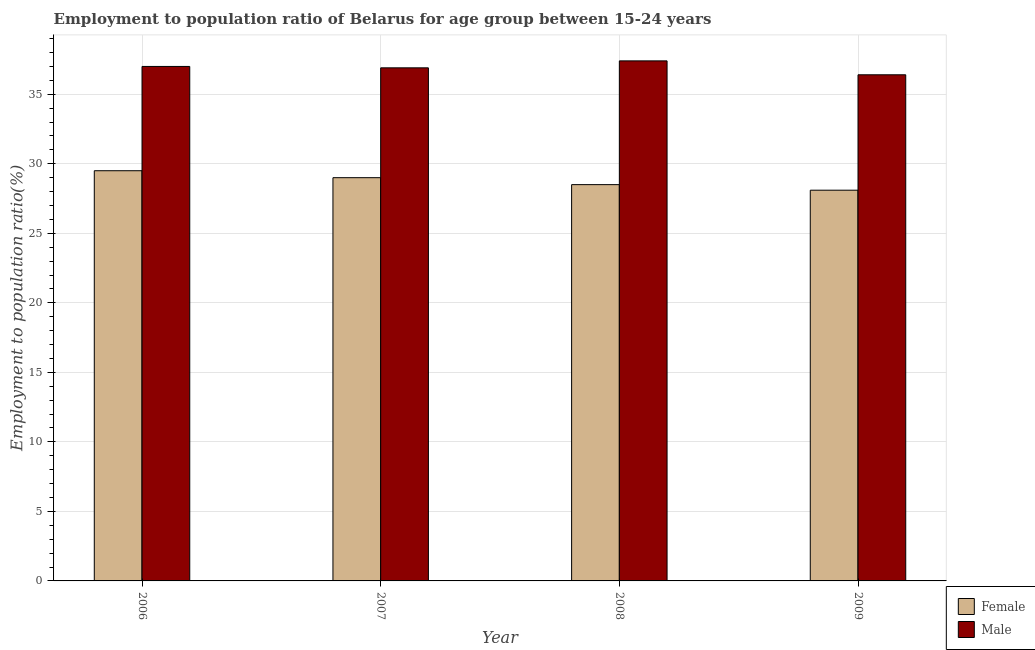Are the number of bars per tick equal to the number of legend labels?
Your answer should be very brief. Yes. What is the label of the 4th group of bars from the left?
Your answer should be very brief. 2009. What is the employment to population ratio(male) in 2009?
Your answer should be very brief. 36.4. Across all years, what is the maximum employment to population ratio(male)?
Offer a terse response. 37.4. Across all years, what is the minimum employment to population ratio(male)?
Make the answer very short. 36.4. In which year was the employment to population ratio(male) minimum?
Give a very brief answer. 2009. What is the total employment to population ratio(male) in the graph?
Make the answer very short. 147.7. What is the difference between the employment to population ratio(female) in 2009 and the employment to population ratio(male) in 2006?
Your answer should be compact. -1.4. What is the average employment to population ratio(male) per year?
Give a very brief answer. 36.93. What is the ratio of the employment to population ratio(female) in 2006 to that in 2007?
Make the answer very short. 1.02. Is the difference between the employment to population ratio(male) in 2006 and 2009 greater than the difference between the employment to population ratio(female) in 2006 and 2009?
Keep it short and to the point. No. What is the difference between the highest and the lowest employment to population ratio(female)?
Provide a short and direct response. 1.4. Is the sum of the employment to population ratio(female) in 2006 and 2008 greater than the maximum employment to population ratio(male) across all years?
Your response must be concise. Yes. What does the 2nd bar from the left in 2007 represents?
Your response must be concise. Male. Are all the bars in the graph horizontal?
Offer a very short reply. No. How many years are there in the graph?
Ensure brevity in your answer.  4. Are the values on the major ticks of Y-axis written in scientific E-notation?
Give a very brief answer. No. Where does the legend appear in the graph?
Make the answer very short. Bottom right. How many legend labels are there?
Ensure brevity in your answer.  2. What is the title of the graph?
Your answer should be compact. Employment to population ratio of Belarus for age group between 15-24 years. Does "Primary" appear as one of the legend labels in the graph?
Keep it short and to the point. No. What is the label or title of the X-axis?
Make the answer very short. Year. What is the label or title of the Y-axis?
Your answer should be very brief. Employment to population ratio(%). What is the Employment to population ratio(%) in Female in 2006?
Your answer should be very brief. 29.5. What is the Employment to population ratio(%) in Male in 2006?
Provide a short and direct response. 37. What is the Employment to population ratio(%) of Male in 2007?
Your answer should be very brief. 36.9. What is the Employment to population ratio(%) in Female in 2008?
Offer a terse response. 28.5. What is the Employment to population ratio(%) in Male in 2008?
Your response must be concise. 37.4. What is the Employment to population ratio(%) of Female in 2009?
Offer a terse response. 28.1. What is the Employment to population ratio(%) in Male in 2009?
Provide a short and direct response. 36.4. Across all years, what is the maximum Employment to population ratio(%) in Female?
Offer a terse response. 29.5. Across all years, what is the maximum Employment to population ratio(%) of Male?
Offer a very short reply. 37.4. Across all years, what is the minimum Employment to population ratio(%) of Female?
Offer a terse response. 28.1. Across all years, what is the minimum Employment to population ratio(%) in Male?
Your answer should be compact. 36.4. What is the total Employment to population ratio(%) of Female in the graph?
Your answer should be very brief. 115.1. What is the total Employment to population ratio(%) in Male in the graph?
Keep it short and to the point. 147.7. What is the difference between the Employment to population ratio(%) in Female in 2006 and that in 2007?
Ensure brevity in your answer.  0.5. What is the difference between the Employment to population ratio(%) of Male in 2006 and that in 2008?
Your answer should be very brief. -0.4. What is the difference between the Employment to population ratio(%) in Female in 2006 and that in 2009?
Ensure brevity in your answer.  1.4. What is the difference between the Employment to population ratio(%) of Male in 2006 and that in 2009?
Your answer should be very brief. 0.6. What is the difference between the Employment to population ratio(%) in Male in 2007 and that in 2008?
Your response must be concise. -0.5. What is the difference between the Employment to population ratio(%) in Male in 2008 and that in 2009?
Your answer should be compact. 1. What is the difference between the Employment to population ratio(%) of Female in 2007 and the Employment to population ratio(%) of Male in 2008?
Ensure brevity in your answer.  -8.4. What is the difference between the Employment to population ratio(%) of Female in 2008 and the Employment to population ratio(%) of Male in 2009?
Your response must be concise. -7.9. What is the average Employment to population ratio(%) of Female per year?
Make the answer very short. 28.77. What is the average Employment to population ratio(%) in Male per year?
Give a very brief answer. 36.92. In the year 2006, what is the difference between the Employment to population ratio(%) in Female and Employment to population ratio(%) in Male?
Your answer should be very brief. -7.5. In the year 2007, what is the difference between the Employment to population ratio(%) in Female and Employment to population ratio(%) in Male?
Make the answer very short. -7.9. In the year 2008, what is the difference between the Employment to population ratio(%) of Female and Employment to population ratio(%) of Male?
Give a very brief answer. -8.9. What is the ratio of the Employment to population ratio(%) in Female in 2006 to that in 2007?
Your answer should be very brief. 1.02. What is the ratio of the Employment to population ratio(%) in Male in 2006 to that in 2007?
Offer a terse response. 1. What is the ratio of the Employment to population ratio(%) of Female in 2006 to that in 2008?
Your answer should be very brief. 1.04. What is the ratio of the Employment to population ratio(%) in Male in 2006 to that in 2008?
Give a very brief answer. 0.99. What is the ratio of the Employment to population ratio(%) in Female in 2006 to that in 2009?
Provide a succinct answer. 1.05. What is the ratio of the Employment to population ratio(%) of Male in 2006 to that in 2009?
Offer a very short reply. 1.02. What is the ratio of the Employment to population ratio(%) of Female in 2007 to that in 2008?
Provide a succinct answer. 1.02. What is the ratio of the Employment to population ratio(%) of Male in 2007 to that in 2008?
Your answer should be compact. 0.99. What is the ratio of the Employment to population ratio(%) of Female in 2007 to that in 2009?
Give a very brief answer. 1.03. What is the ratio of the Employment to population ratio(%) in Male in 2007 to that in 2009?
Ensure brevity in your answer.  1.01. What is the ratio of the Employment to population ratio(%) of Female in 2008 to that in 2009?
Give a very brief answer. 1.01. What is the ratio of the Employment to population ratio(%) in Male in 2008 to that in 2009?
Offer a very short reply. 1.03. What is the difference between the highest and the second highest Employment to population ratio(%) of Female?
Provide a short and direct response. 0.5. What is the difference between the highest and the second highest Employment to population ratio(%) in Male?
Make the answer very short. 0.4. 